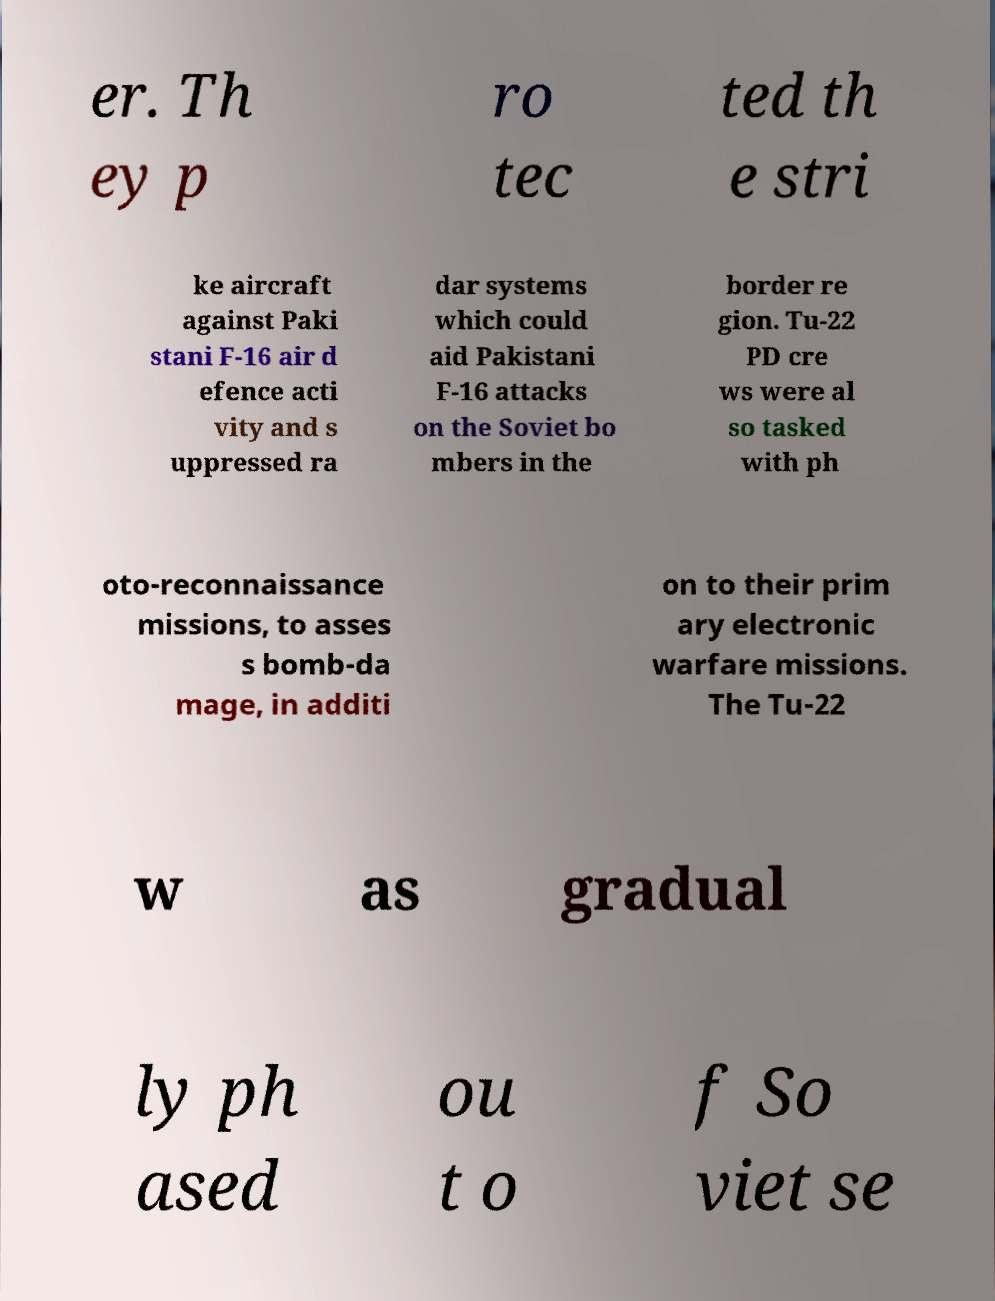Please identify and transcribe the text found in this image. er. Th ey p ro tec ted th e stri ke aircraft against Paki stani F-16 air d efence acti vity and s uppressed ra dar systems which could aid Pakistani F-16 attacks on the Soviet bo mbers in the border re gion. Tu-22 PD cre ws were al so tasked with ph oto-reconnaissance missions, to asses s bomb-da mage, in additi on to their prim ary electronic warfare missions. The Tu-22 w as gradual ly ph ased ou t o f So viet se 